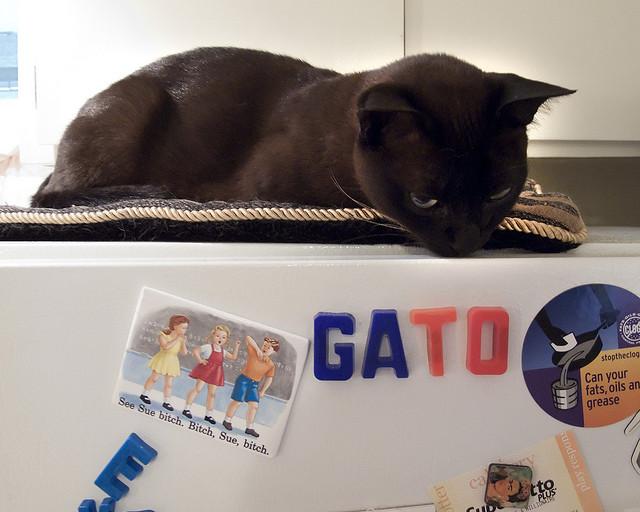Does the cat have a thing for shoes?
Quick response, please. No. What is the cat lying on?
Give a very brief answer. Fridge. Is the cat looking at the stickers?
Write a very short answer. No. What is the word under the cat?
Write a very short answer. Gato. 